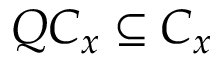<formula> <loc_0><loc_0><loc_500><loc_500>Q C _ { x } \subseteq C _ { x }</formula> 